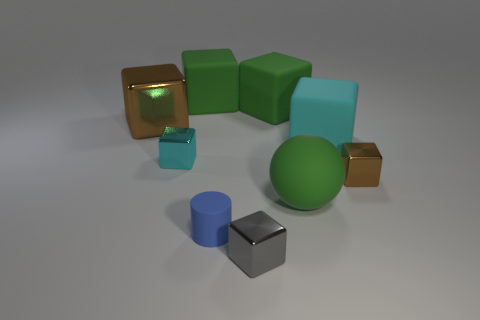Subtract all large green cubes. How many cubes are left? 5 Add 1 brown blocks. How many objects exist? 10 Subtract 1 cylinders. How many cylinders are left? 0 Subtract all cylinders. How many objects are left? 8 Subtract all gray blocks. How many blocks are left? 6 Subtract 2 cyan cubes. How many objects are left? 7 Subtract all purple blocks. Subtract all cyan cylinders. How many blocks are left? 7 Subtract all gray spheres. How many cyan cylinders are left? 0 Subtract all large green things. Subtract all big cubes. How many objects are left? 2 Add 9 large green balls. How many large green balls are left? 10 